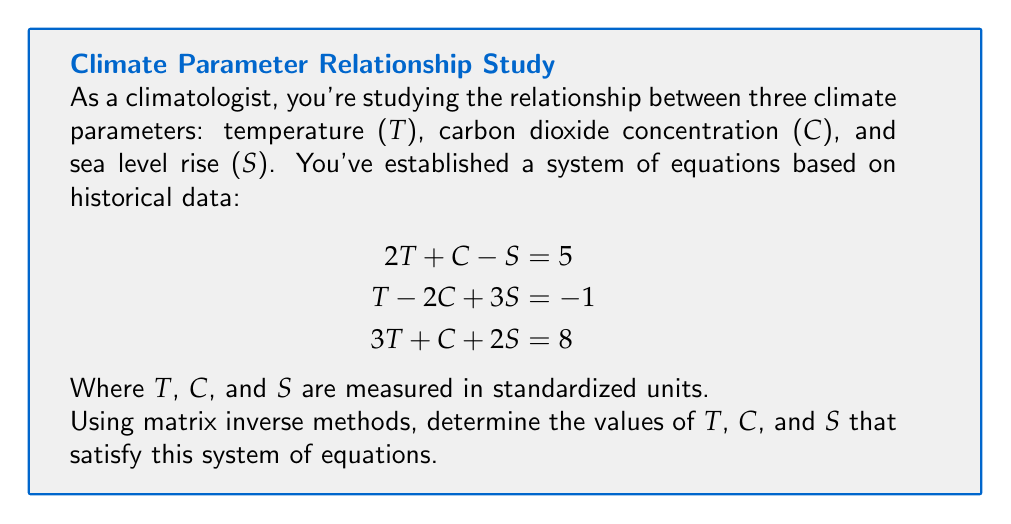What is the answer to this math problem? To solve this system using matrix inverse methods, we'll follow these steps:

1) First, we'll express the system in matrix form AX = B:

   $$
   \begin{bmatrix}
   2 & 1 & -1 \\
   1 & -2 & 3 \\
   3 & 1 & 2
   \end{bmatrix}
   \begin{bmatrix}
   T \\
   C \\
   S
   \end{bmatrix}
   =
   \begin{bmatrix}
   5 \\
   -1 \\
   8
   \end{bmatrix}
   $$

2) To solve for X, we need to find $A^{-1}$. We'll use the adjugate method:

   $A^{-1} = \frac{1}{det(A)} \cdot adj(A)$

3) Calculate $det(A)$:
   
   $det(A) = 2(-2)(2) + 1(3)(3) + (-1)(1)(1) - (-1)(-2)(3) - 2(3)(1) - 1(1)(2) = -8 + 9 - 1 + 6 - 6 - 2 = -2$

4) Calculate $adj(A)$:

   $$
   adj(A) = 
   \begin{bmatrix}
   (-2)(2) - (3)(1) & -[(1)(2) - (-1)(1)] & (1)(3) - (-2)(-1) \\
   -[(1)(2) - (-1)(3)] & (2)(2) - (-1)(3) & -[(2)(3) - (1)(-1)] \\
   (1)(1) - (-2)(3) & -[(2)(1) - (1)(3)] & (2)(-2) - (1)(1)
   \end{bmatrix}
   $$

   $$
   adj(A) = 
   \begin{bmatrix}
   -7 & -3 & 5 \\
   -5 & 7 & -7 \\
   7 & -5 & -5
   \end{bmatrix}
   $$

5) Calculate $A^{-1}$:

   $$
   A^{-1} = -\frac{1}{2}
   \begin{bmatrix}
   -7 & -3 & 5 \\
   -5 & 7 & -7 \\
   7 & -5 & -5
   \end{bmatrix}
   =
   \begin{bmatrix}
   \frac{7}{2} & \frac{3}{2} & -\frac{5}{2} \\
   \frac{5}{2} & -\frac{7}{2} & \frac{7}{2} \\
   -\frac{7}{2} & \frac{5}{2} & \frac{5}{2}
   \end{bmatrix}
   $$

6) Solve for X:

   $$
   \begin{bmatrix}
   T \\
   C \\
   S
   \end{bmatrix}
   =
   \begin{bmatrix}
   \frac{7}{2} & \frac{3}{2} & -\frac{5}{2} \\
   \frac{5}{2} & -\frac{7}{2} & \frac{7}{2} \\
   -\frac{7}{2} & \frac{5}{2} & \frac{5}{2}
   \end{bmatrix}
   \begin{bmatrix}
   5 \\
   -1 \\
   8
   \end{bmatrix}
   $$

7) Multiply the matrices:

   $$
   \begin{bmatrix}
   T \\
   C \\
   S
   \end{bmatrix}
   =
   \begin{bmatrix}
   \frac{7}{2}(5) + \frac{3}{2}(-1) + (-\frac{5}{2})(8) \\
   \frac{5}{2}(5) + (-\frac{7}{2})(-1) + \frac{7}{2}(8) \\
   (-\frac{7}{2})(5) + \frac{5}{2}(-1) + \frac{5}{2}(8)
   \end{bmatrix}
   =
   \begin{bmatrix}
   1 \\
   2 \\
   0
   \end{bmatrix}
   $$
Answer: $T = 1, C = 2, S = 0$ 